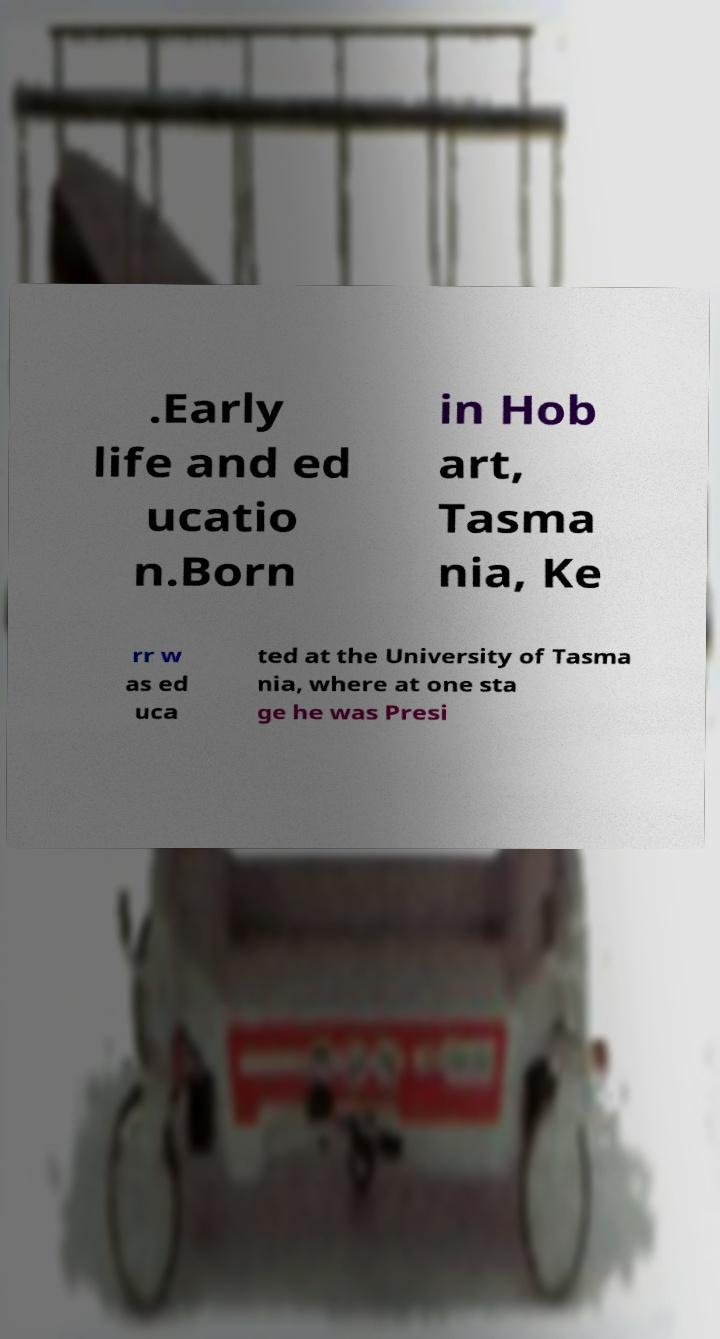Please identify and transcribe the text found in this image. .Early life and ed ucatio n.Born in Hob art, Tasma nia, Ke rr w as ed uca ted at the University of Tasma nia, where at one sta ge he was Presi 